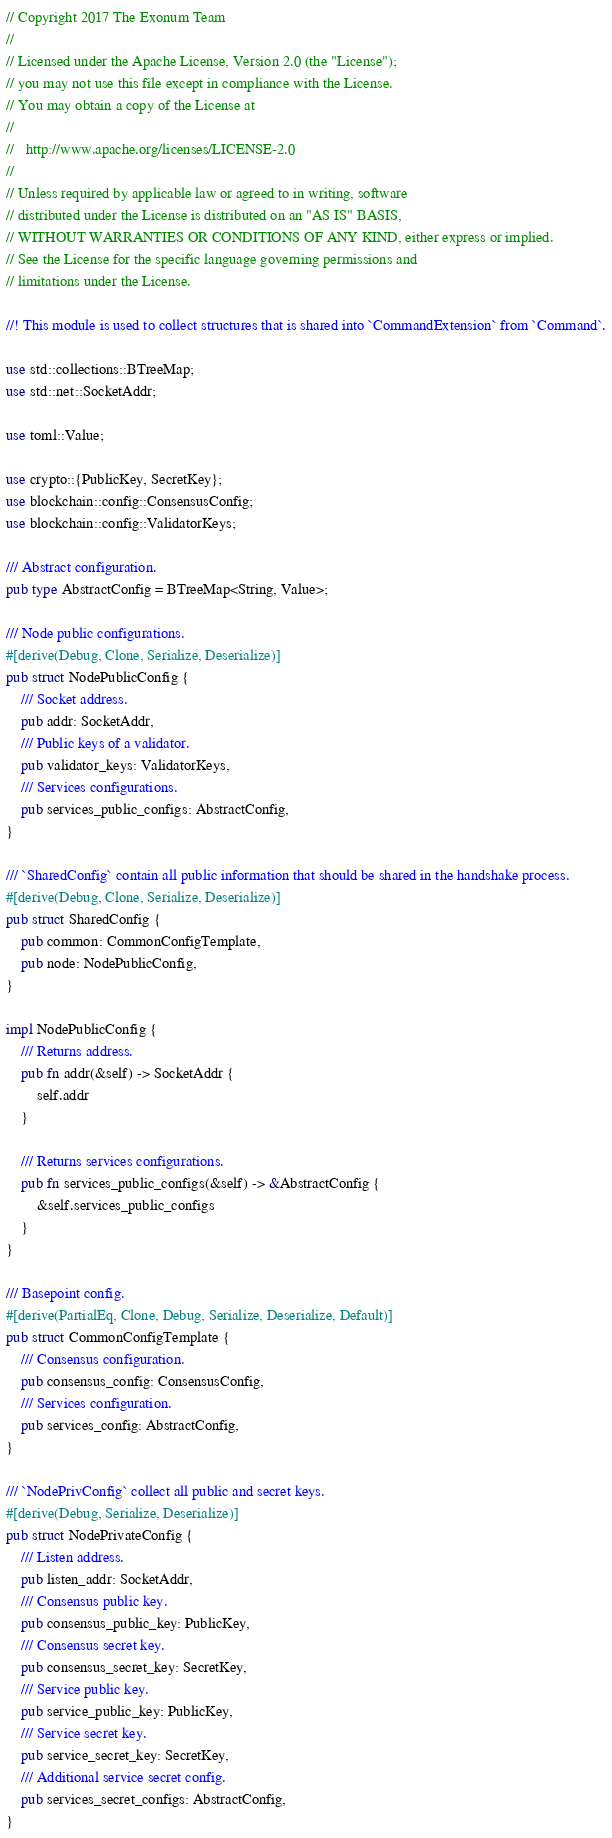<code> <loc_0><loc_0><loc_500><loc_500><_Rust_>// Copyright 2017 The Exonum Team
//
// Licensed under the Apache License, Version 2.0 (the "License");
// you may not use this file except in compliance with the License.
// You may obtain a copy of the License at
//
//   http://www.apache.org/licenses/LICENSE-2.0
//
// Unless required by applicable law or agreed to in writing, software
// distributed under the License is distributed on an "AS IS" BASIS,
// WITHOUT WARRANTIES OR CONDITIONS OF ANY KIND, either express or implied.
// See the License for the specific language governing permissions and
// limitations under the License.

//! This module is used to collect structures that is shared into `CommandExtension` from `Command`.

use std::collections::BTreeMap;
use std::net::SocketAddr;

use toml::Value;

use crypto::{PublicKey, SecretKey};
use blockchain::config::ConsensusConfig;
use blockchain::config::ValidatorKeys;

/// Abstract configuration.
pub type AbstractConfig = BTreeMap<String, Value>;

/// Node public configurations.
#[derive(Debug, Clone, Serialize, Deserialize)]
pub struct NodePublicConfig {
    /// Socket address.
    pub addr: SocketAddr,
    /// Public keys of a validator.
    pub validator_keys: ValidatorKeys,
    /// Services configurations.
    pub services_public_configs: AbstractConfig,
}

/// `SharedConfig` contain all public information that should be shared in the handshake process.
#[derive(Debug, Clone, Serialize, Deserialize)]
pub struct SharedConfig {
    pub common: CommonConfigTemplate,
    pub node: NodePublicConfig,
}

impl NodePublicConfig {
    /// Returns address.
    pub fn addr(&self) -> SocketAddr {
        self.addr
    }

    /// Returns services configurations.
    pub fn services_public_configs(&self) -> &AbstractConfig {
        &self.services_public_configs
    }
}

/// Basepoint config.
#[derive(PartialEq, Clone, Debug, Serialize, Deserialize, Default)]
pub struct CommonConfigTemplate {
    /// Consensus configuration.
    pub consensus_config: ConsensusConfig,
    /// Services configuration.
    pub services_config: AbstractConfig,
}

/// `NodePrivConfig` collect all public and secret keys.
#[derive(Debug, Serialize, Deserialize)]
pub struct NodePrivateConfig {
    /// Listen address.
    pub listen_addr: SocketAddr,
    /// Consensus public key.
    pub consensus_public_key: PublicKey,
    /// Consensus secret key.
    pub consensus_secret_key: SecretKey,
    /// Service public key.
    pub service_public_key: PublicKey,
    /// Service secret key.
    pub service_secret_key: SecretKey,
    /// Additional service secret config.
    pub services_secret_configs: AbstractConfig,
}
</code> 